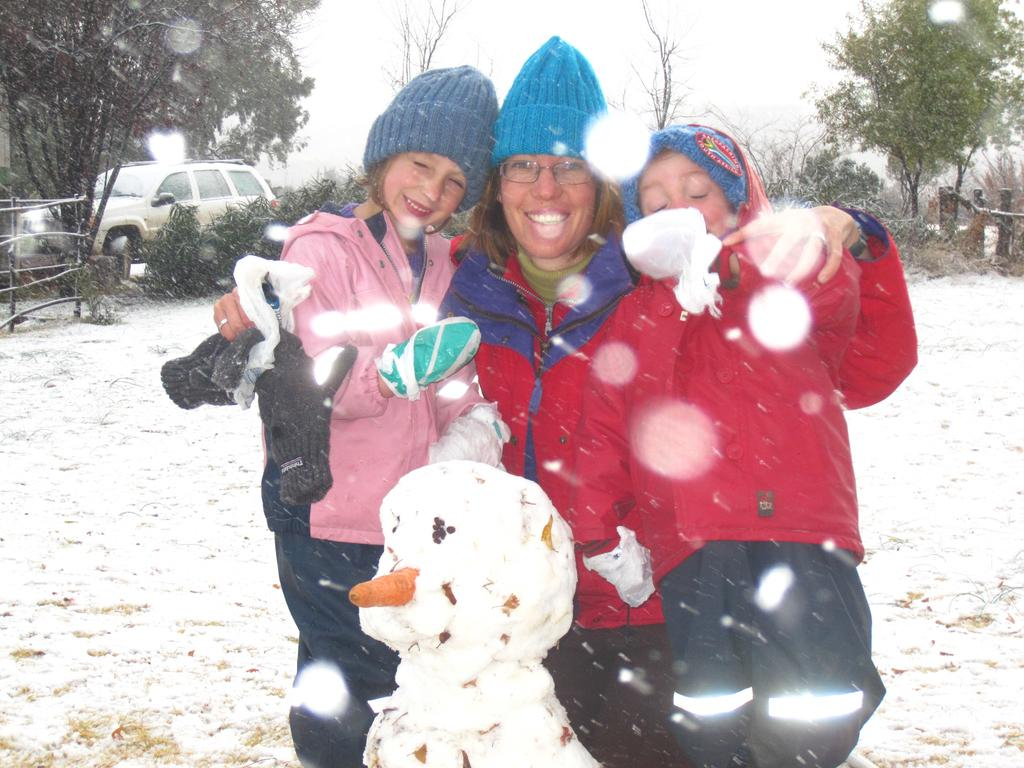Who is present in the image? There is a lady and two girls in the image. What is the surface they are standing on? They are standing on a snow floor. What can be seen in the background of the image? There is a car, trees, and boundaries in the background of the image. What type of sheet is covering the car in the image? There is no sheet covering the car in the image; it is visible in the background. 